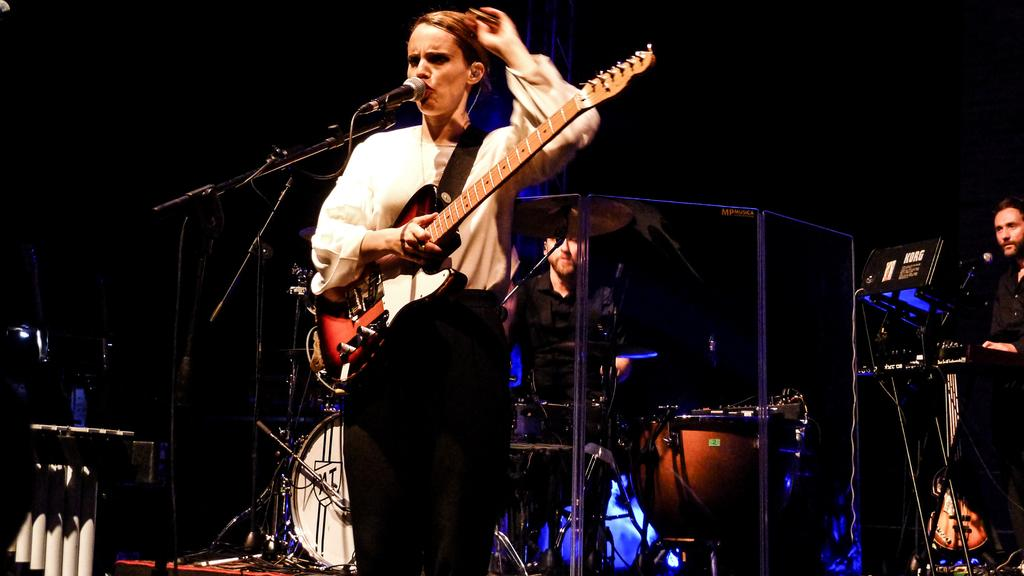Who is the main subject in the image? There is a woman in the image. What is the woman holding in the image? The woman is holding a guitar. What is the woman doing with the microphone? The woman is singing into a microphone. What can be seen in the background of the image? There are people playing musical instruments in the background. What type of brush is the woman using to paint her wings in the image? There is no brush or wings present in the image; the woman is holding a guitar and singing into a microphone. 